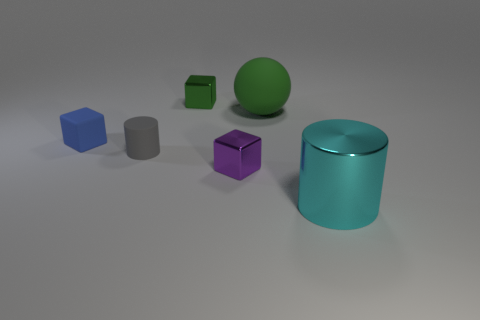If the gray cylinder is considered the central point of the image, can you describe the spatial arrangement of the other objects in relation to it? Taking the gray cylinder as the central point, we have a blue cube and a green cube placed respectively behind it. To the right of the gray cylinder is a shiny purple cube, slightly in the foreground compared to the cylinder. In front of the gray cylinder and slightly to the left, there's a large, shiny teal cylinder. Lastly, there's a green sphere placed in front of the gray cylinder, off to the side and slightly overlapping visually with the teal cylinder. 